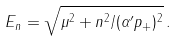Convert formula to latex. <formula><loc_0><loc_0><loc_500><loc_500>E _ { n } = \sqrt { \mu ^ { 2 } + n ^ { 2 } / ( \alpha ^ { \prime } p _ { + } ) ^ { 2 } } \, .</formula> 